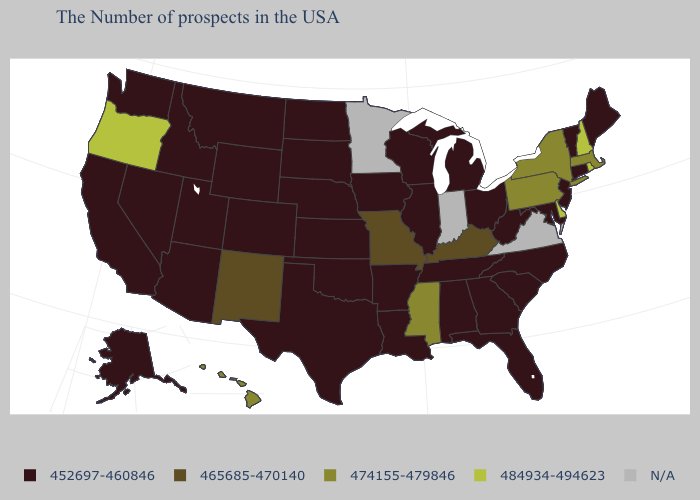What is the value of Pennsylvania?
Short answer required. 474155-479846. Name the states that have a value in the range 484934-494623?
Be succinct. Rhode Island, New Hampshire, Delaware, Oregon. Is the legend a continuous bar?
Answer briefly. No. Among the states that border Utah , which have the highest value?
Be succinct. New Mexico. What is the value of New Mexico?
Keep it brief. 465685-470140. What is the highest value in the Northeast ?
Keep it brief. 484934-494623. Does Rhode Island have the highest value in the USA?
Give a very brief answer. Yes. Name the states that have a value in the range N/A?
Short answer required. Virginia, Indiana, Minnesota. Is the legend a continuous bar?
Concise answer only. No. What is the value of Tennessee?
Give a very brief answer. 452697-460846. Does Mississippi have the lowest value in the USA?
Concise answer only. No. What is the lowest value in the USA?
Keep it brief. 452697-460846. Among the states that border Arizona , does New Mexico have the lowest value?
Concise answer only. No. 